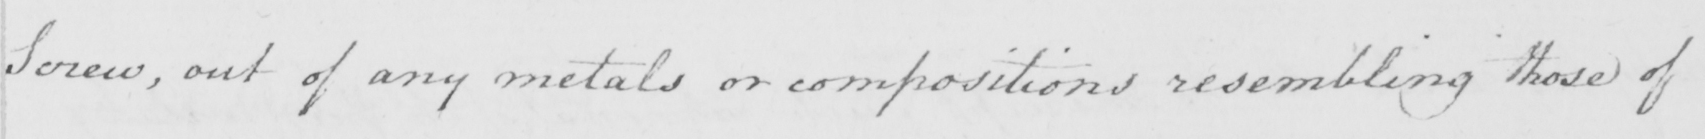Can you read and transcribe this handwriting? Screw , out of any metals or compositions resembling those of 